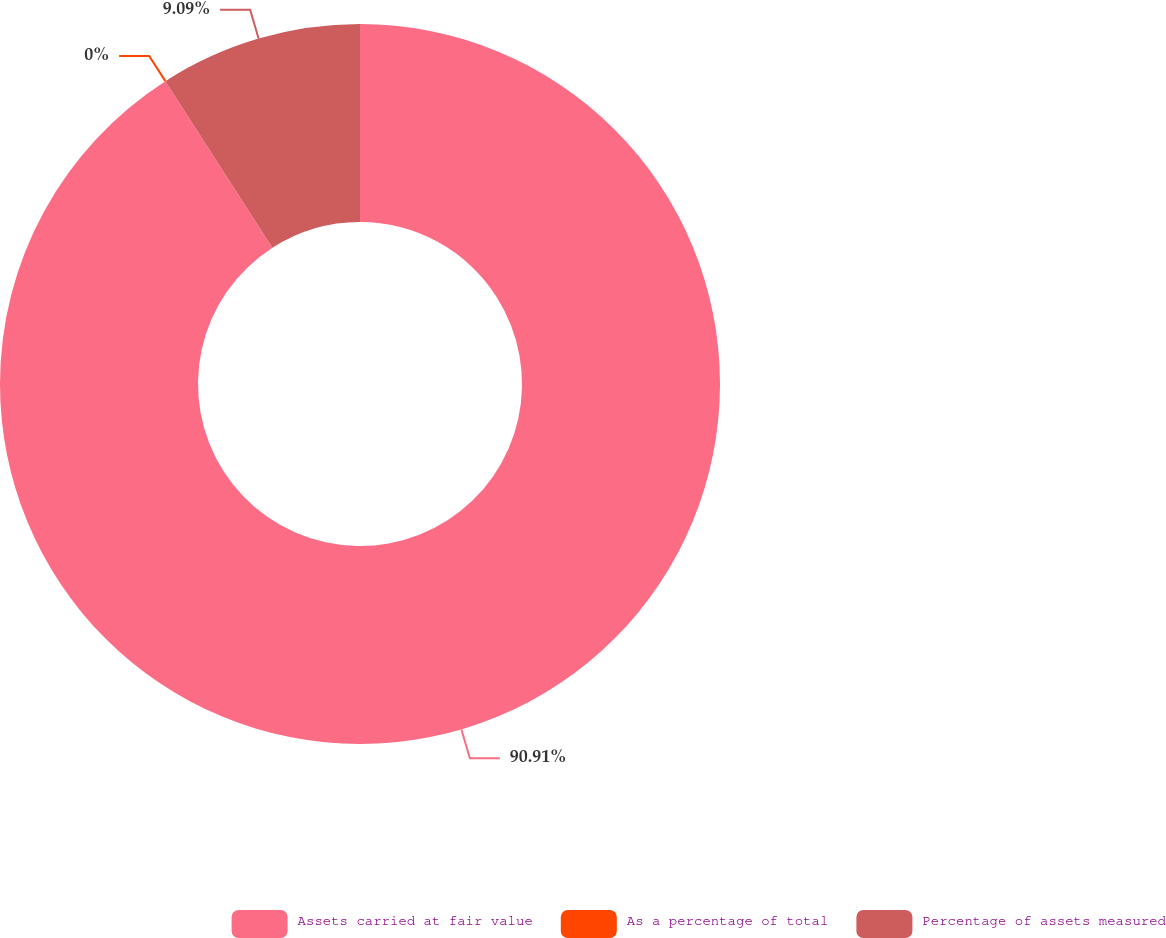Convert chart to OTSL. <chart><loc_0><loc_0><loc_500><loc_500><pie_chart><fcel>Assets carried at fair value<fcel>As a percentage of total<fcel>Percentage of assets measured<nl><fcel>90.91%<fcel>0.0%<fcel>9.09%<nl></chart> 